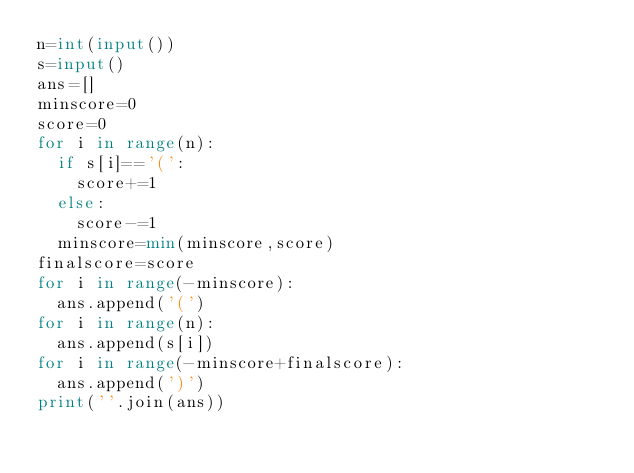Convert code to text. <code><loc_0><loc_0><loc_500><loc_500><_Python_>n=int(input())
s=input()
ans=[]
minscore=0
score=0
for i in range(n):
  if s[i]=='(':
    score+=1
  else:
    score-=1
  minscore=min(minscore,score)
finalscore=score
for i in range(-minscore):
  ans.append('(')
for i in range(n):
  ans.append(s[i])
for i in range(-minscore+finalscore):
  ans.append(')')
print(''.join(ans))</code> 